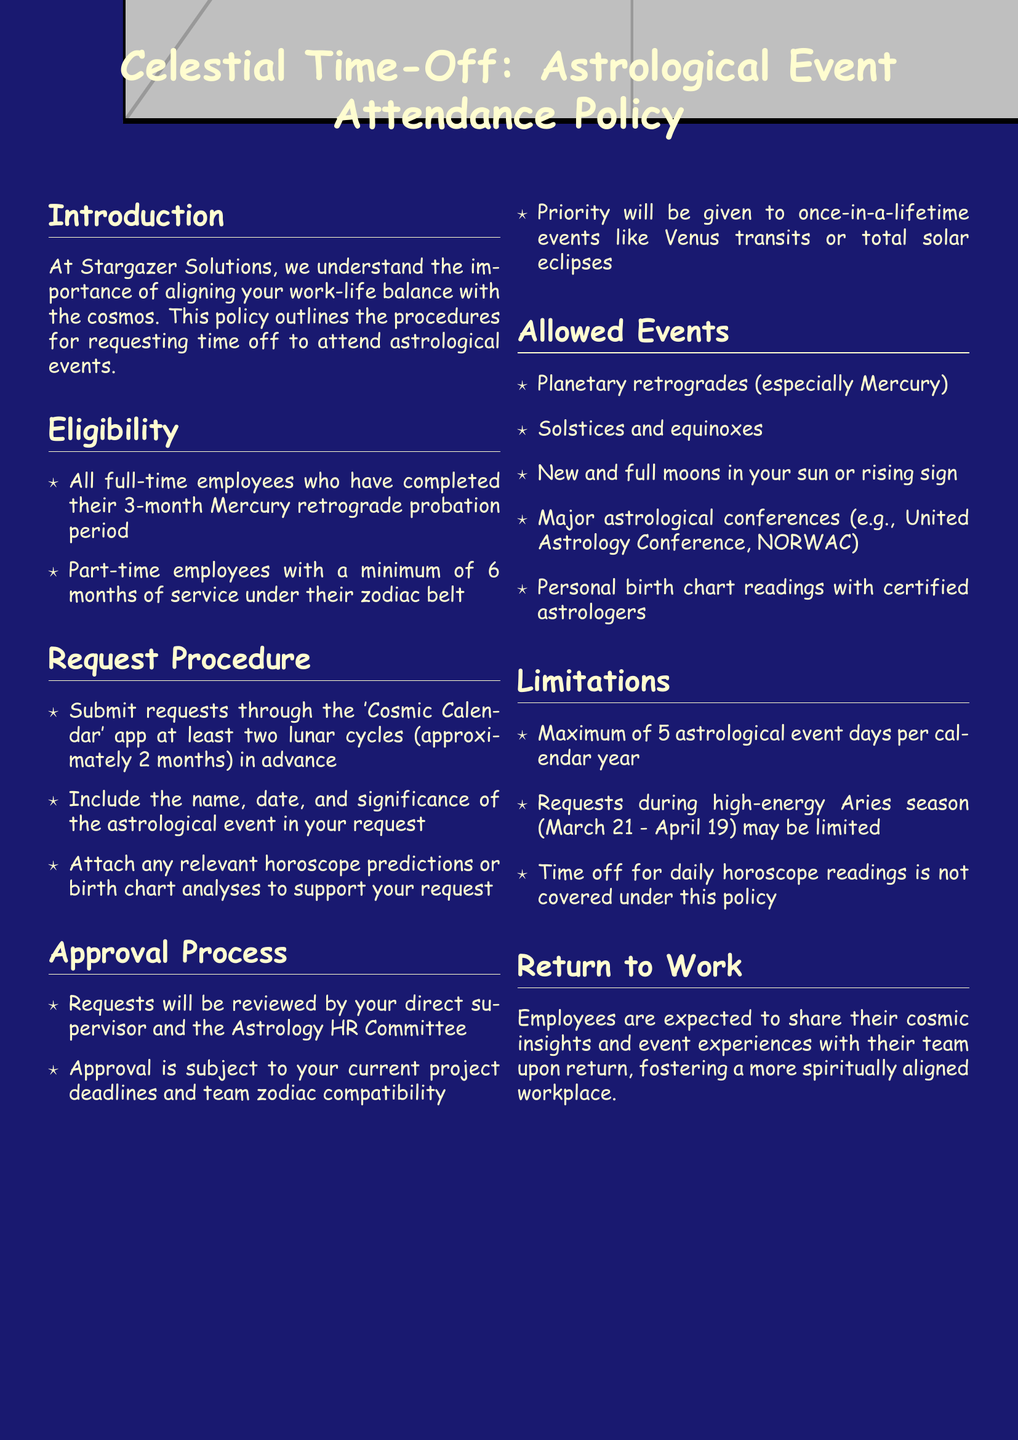What is the title of the policy document? The title is presented prominently at the beginning of the document, indicating the subject clearly.
Answer: Celestial Time-Off: Astrological Event Attendance Policy Who can request time off for astrological events? This information is outlined in the eligibility section, specifying which employee categories qualify.
Answer: Full-time and part-time employees How many lunar cycles in advance must requests be submitted? This detail is found in the request procedure section, indicating the time frame for submissions.
Answer: Two lunar cycles What is the maximum number of astrological event days allowed per year? This limitation is specified in the document, detailing how much time off can be taken for events.
Answer: Five days Which committee is involved in the approval process? The approval process section mentions this committee specifically, indicating who reviews requests.
Answer: Astrology HR Committee Are daily horoscope readings covered under this policy? The limitations section directly addresses this aspect, clarifying exclusions within the policy.
Answer: No What types of events are prioritized for approval? This prioritization is mentioned in the approval process, indicating which events receive special consideration.
Answer: Once-in-a-lifetime events What is expected from employees upon their return? The return to work section outlines the expectations set for employees after attending events.
Answer: Share cosmic insights and experiences 